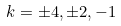<formula> <loc_0><loc_0><loc_500><loc_500>k = \pm 4 , \pm 2 , - 1</formula> 